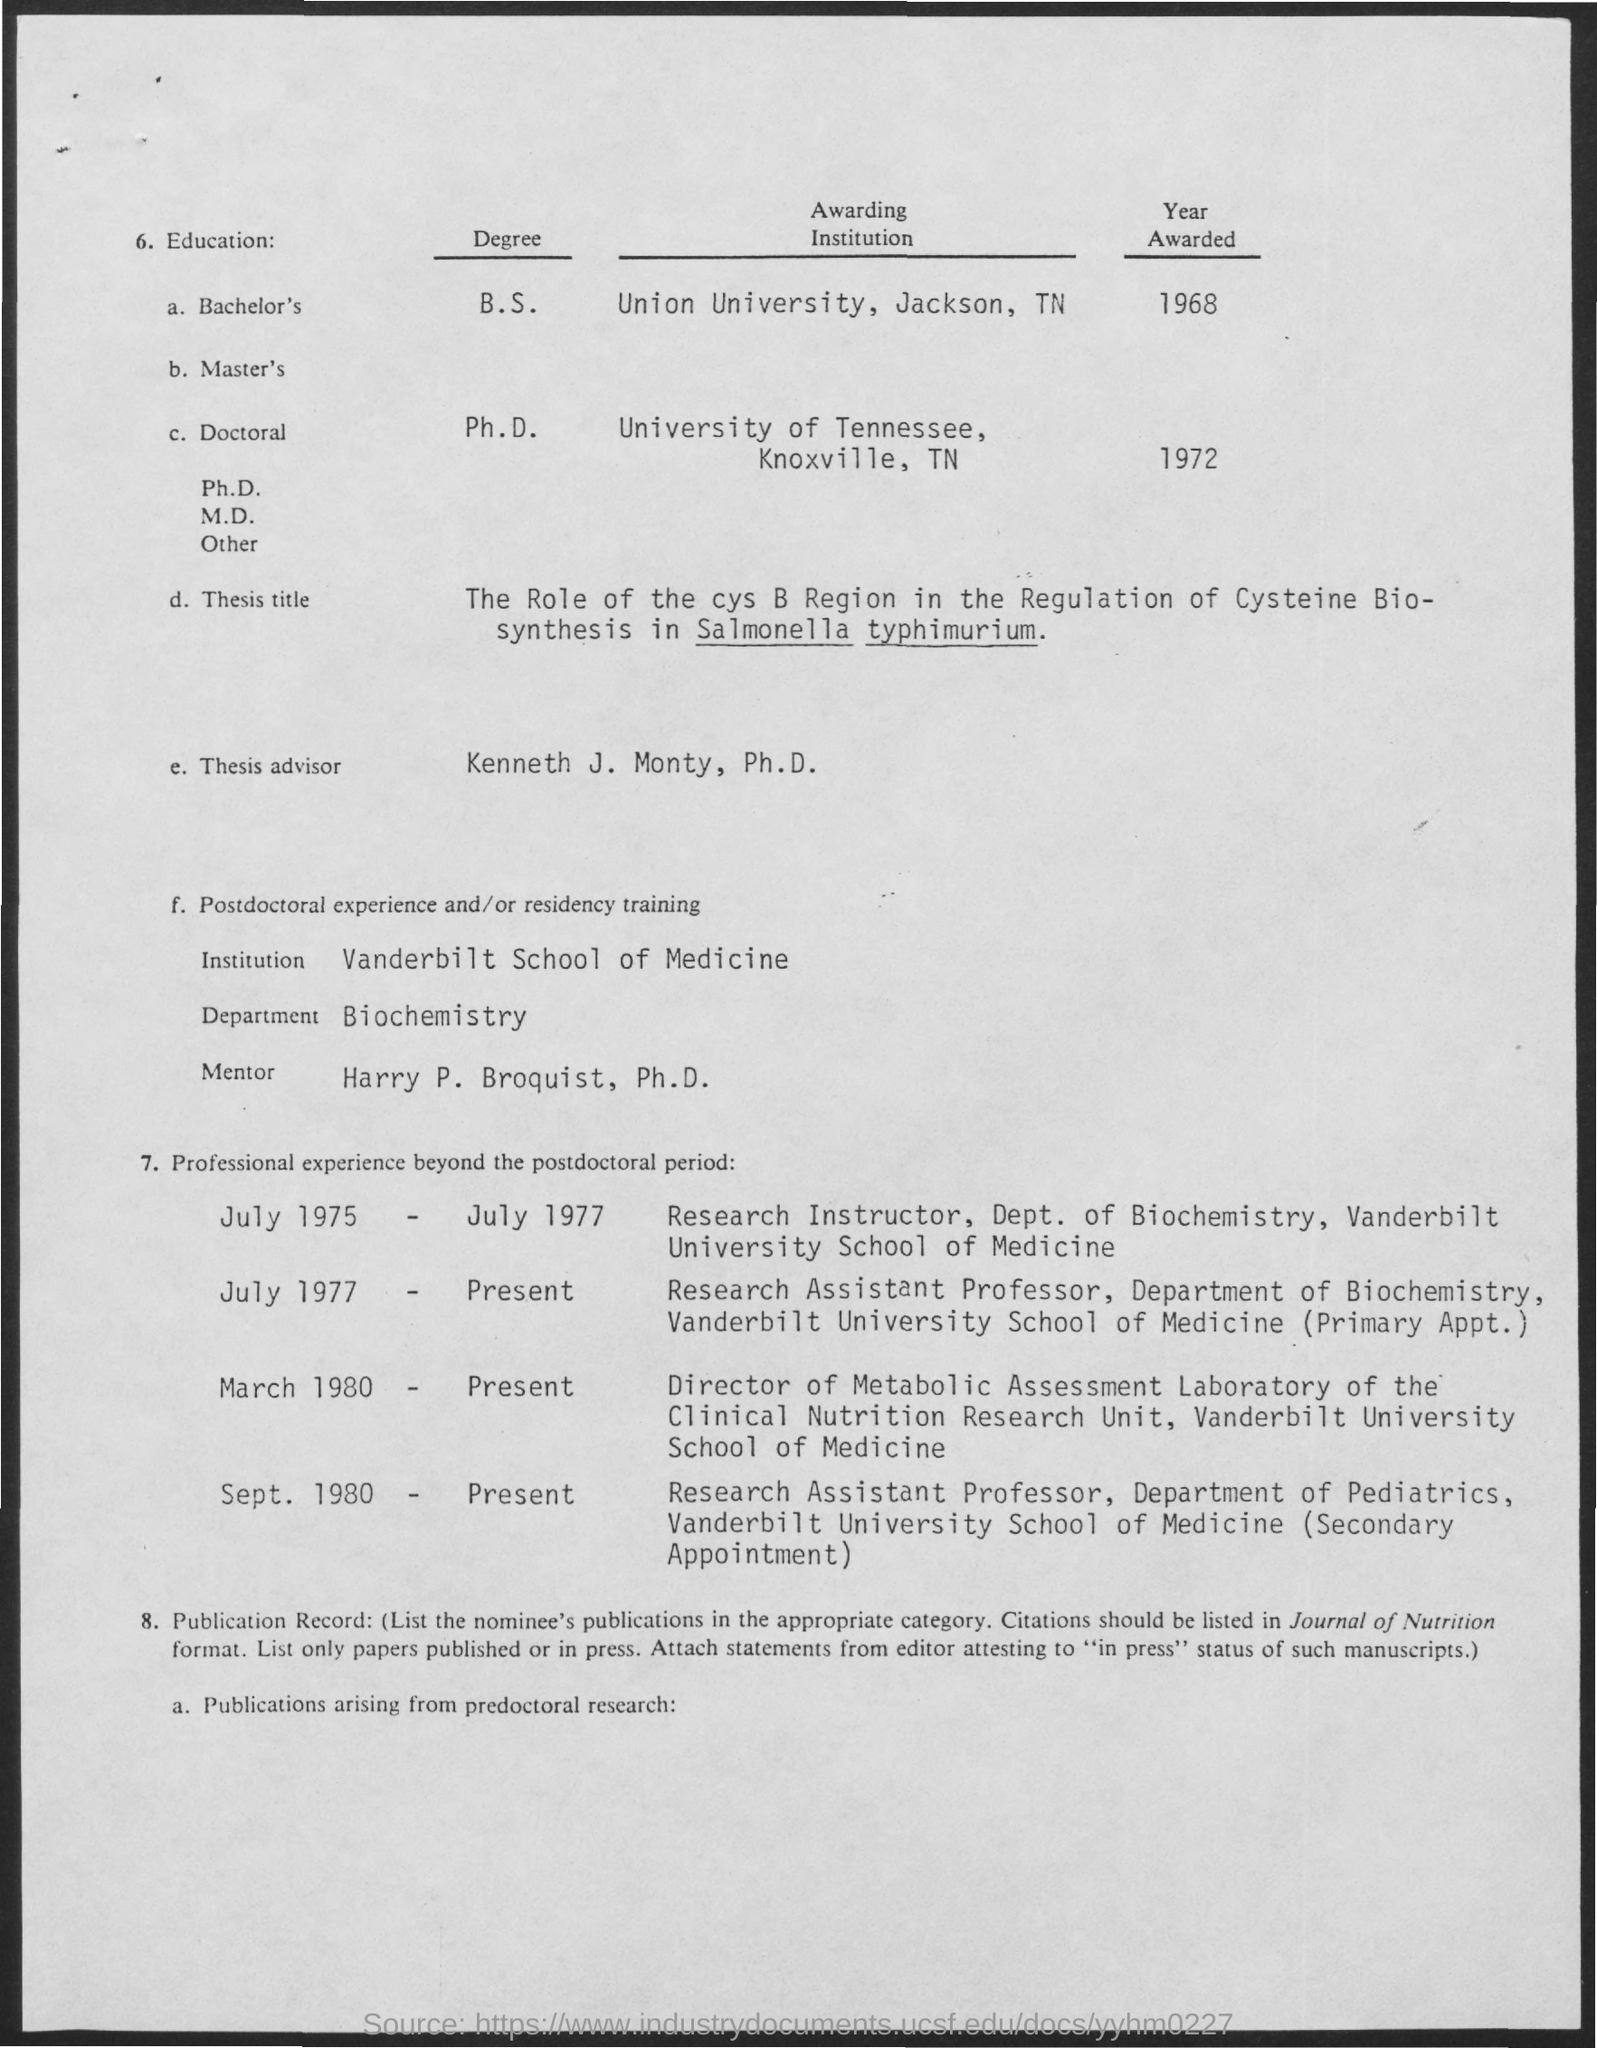Point out several critical features in this image. Vanderbilt School of Medicine is the name of the institution. The name of the thesis advisor mentioned is Kenneth J. Monty, Ph.D. The degree of Ph.D. was awarded in the year 1972. The mentor's name is Harry P. Broquist, Ph.D. The department mentioned in the given form is Biotechnology. 